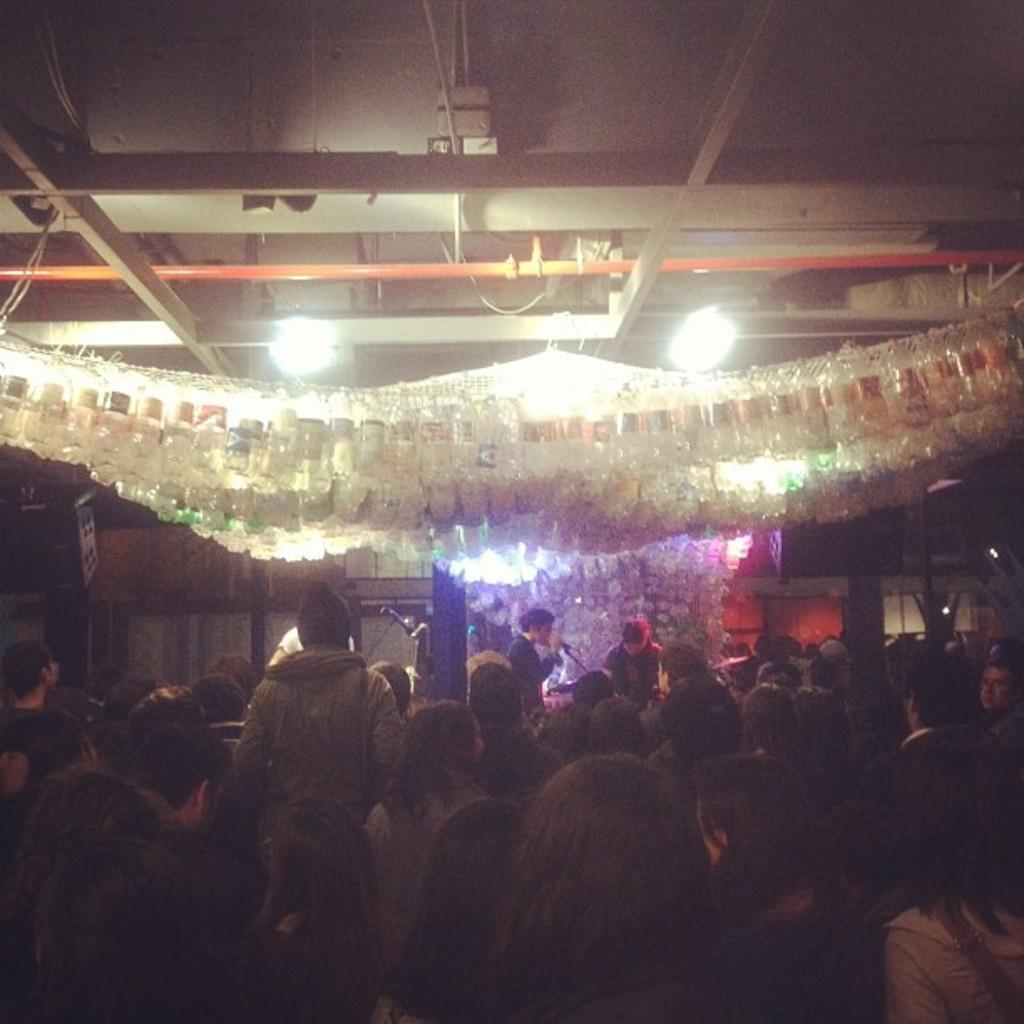What is happening in the image? There are people standing in the image. What can be seen in the background of the image? There are decorations, lights, and a mic in the background of the image. Can you describe the color of the pipe on the ceiling in the image? There is an orange color pipe on the ceiling in the image. How many balls are being juggled by the people in the image? There are no balls present in the image; the people are not juggling. 